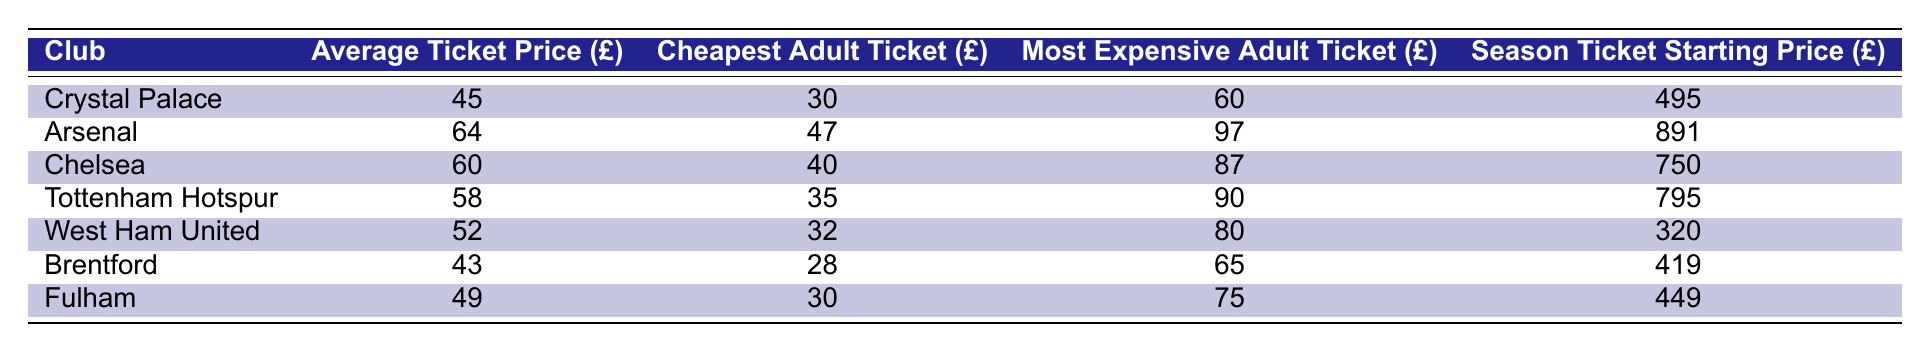What is the cheapest adult ticket price for Crystal Palace? The table has the specific value for the cheapest adult ticket price listed under Crystal Palace, which is £30.
Answer: £30 Which club has the highest average ticket price? By comparing the average ticket prices across all clubs in the table, Arsenal has the highest at £64.
Answer: Arsenal What is the price difference between the most expensive adult ticket at Crystal Palace and Chelsea? The most expensive adult ticket for Crystal Palace is £60, and for Chelsea, it is £87. The difference is £87 - £60 = £27.
Answer: £27 Is the season ticket starting price for Fulham less than that of Crystal Palace? Fulham's season ticket starts at £449, while Crystal Palace's starts at £495. Therefore, £449 is less than £495, making the statement true.
Answer: Yes What is the average ticket price across all the London clubs listed? Adding the average ticket prices: 45 + 64 + 60 + 58 + 52 + 43 + 49 = 371. Then divide by the number of clubs, which is 7. So, the average price is 371/7 ≈ 53. The calculated average is approximately £53.
Answer: £53 How much more do you pay on average for a ticket at Arsenal compared to Brentford? Arsenal's average ticket price is £64, and Brentford's is £43. The difference is £64 - £43 = £21.
Answer: £21 What club offers the cheapest adult ticket? Looking at the table, Brentford offers the cheapest adult ticket at £28.
Answer: Brentford Is Crystal Palace's average ticket price below £50? Crystal Palace’s average ticket price is £45, which is indeed below £50.
Answer: Yes What is the season ticket price difference between West Ham United and Tottenham Hotspur? West Ham United's season ticket starting price is £320, while Tottenham Hotspur's is £795. The difference is £795 - £320 = £475.
Answer: £475 